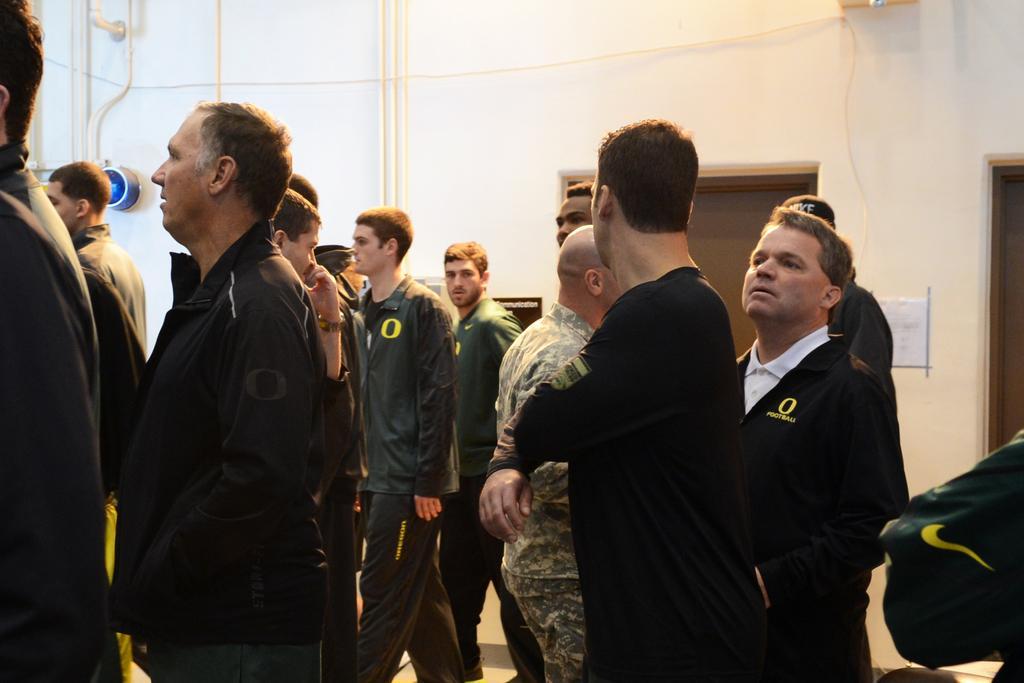Could you give a brief overview of what you see in this image? In the center of the image we can see a group of people are standing. In the background of the image we can see wall, pipes, light, paper, doors are present. 